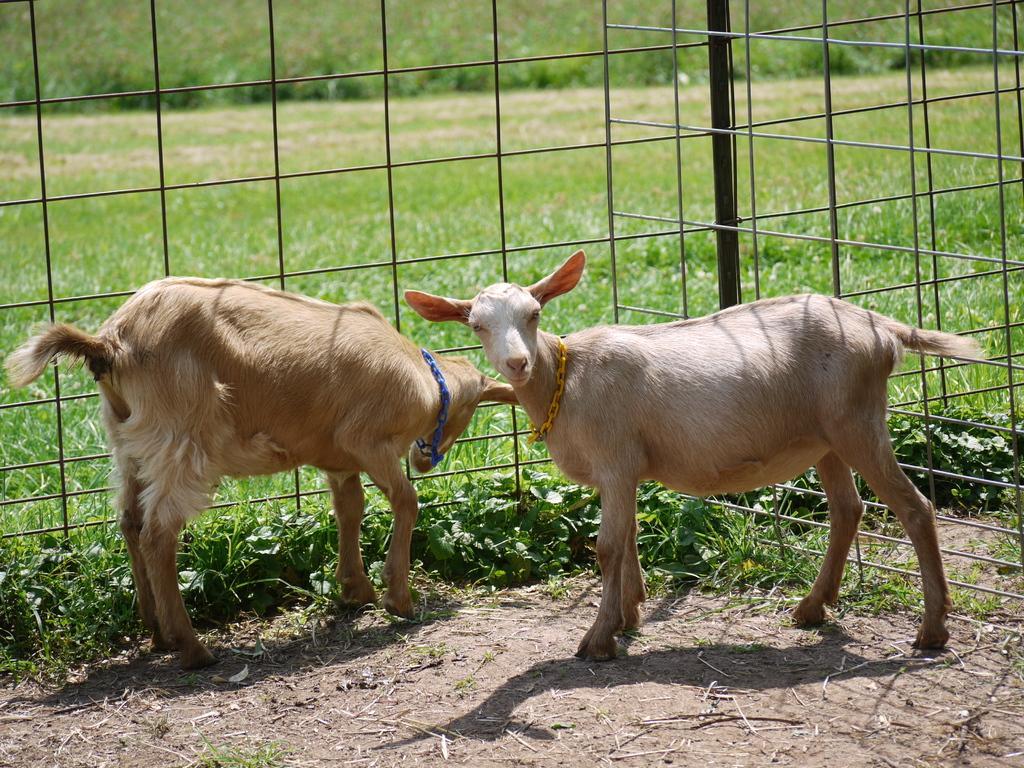Please provide a concise description of this image. In this image I can see two animals in brown and white color. Back I can see a green grass and railing. 